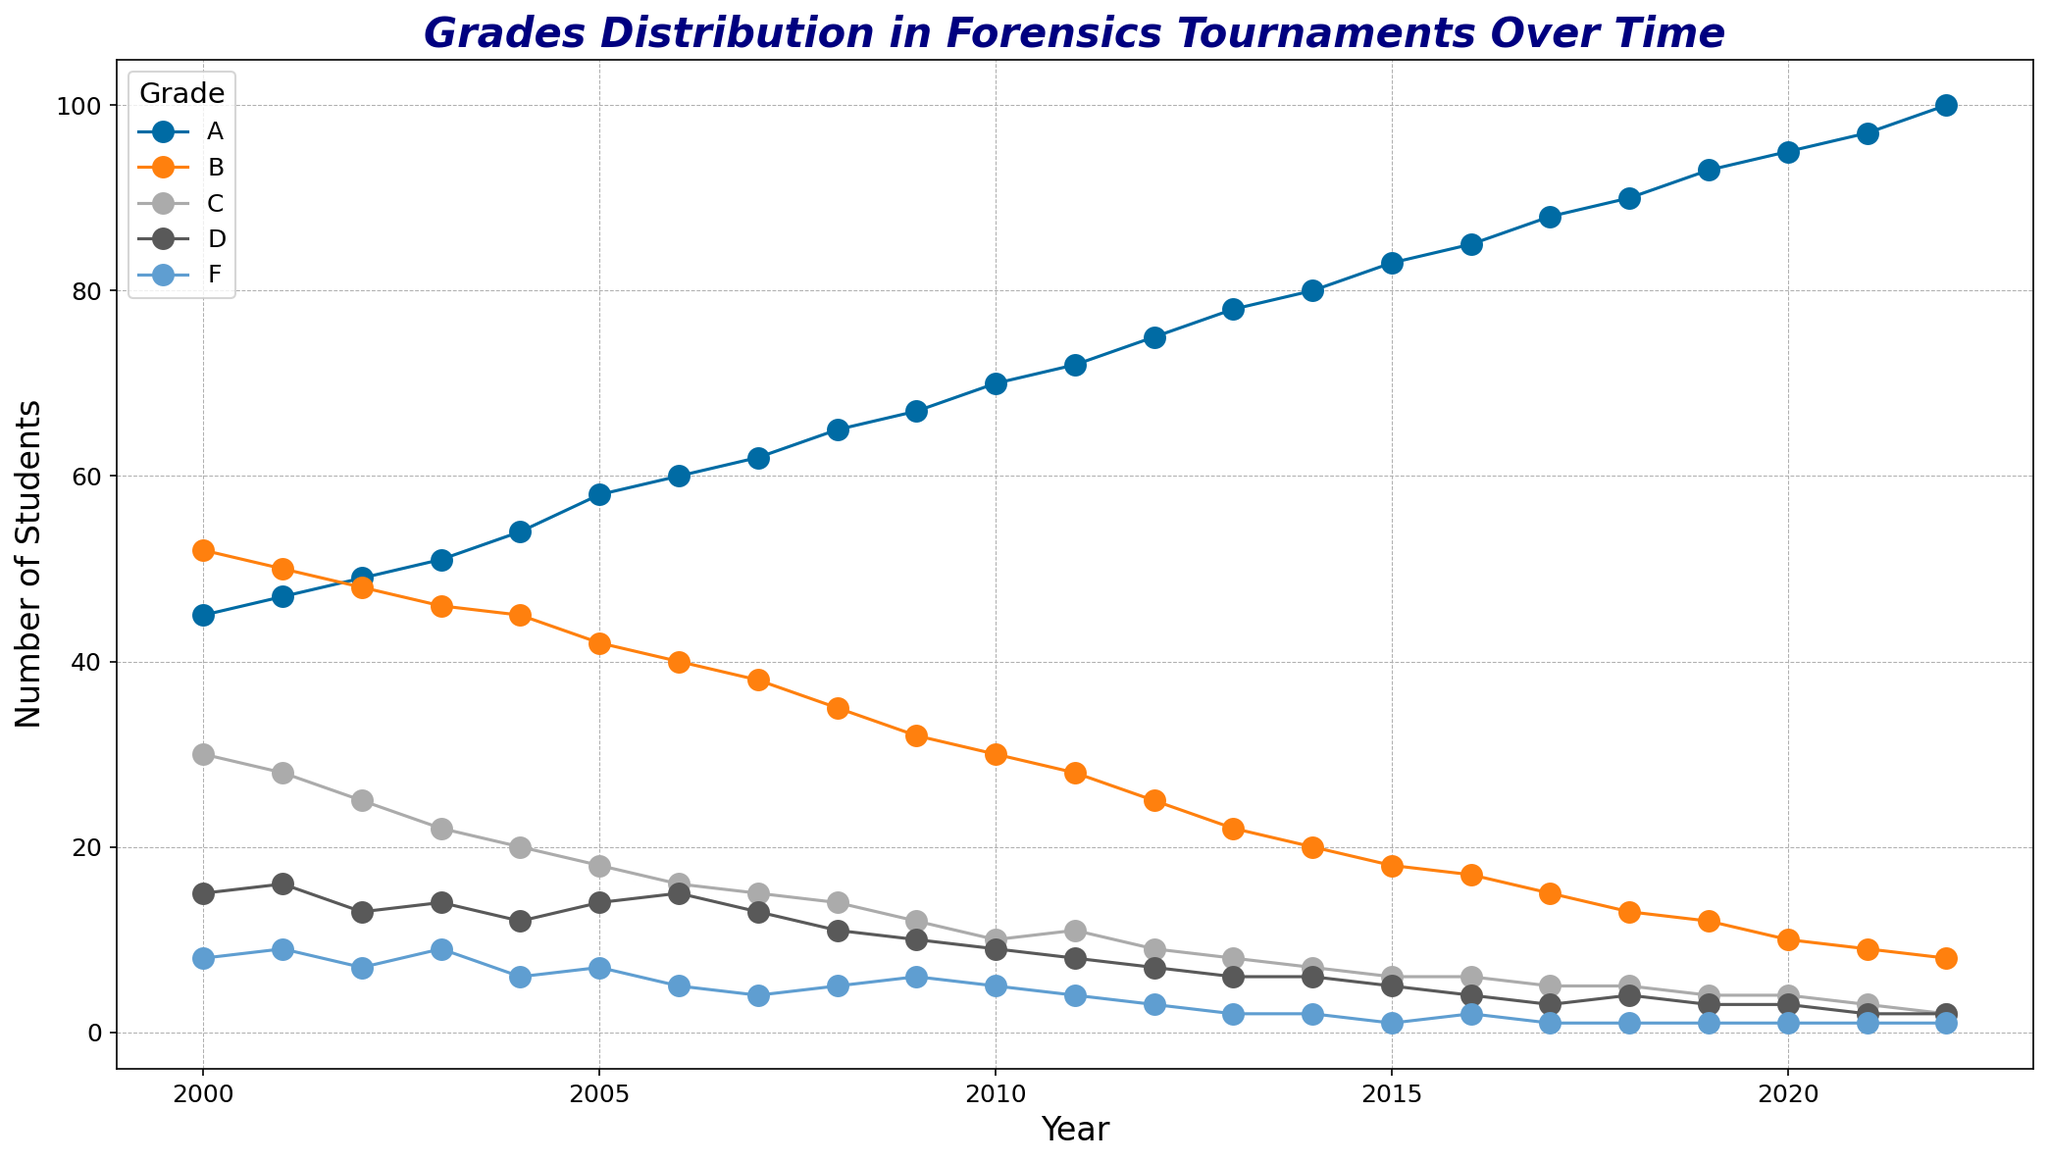Which grade has shown the most students consistently over the years? To determine the grade with the most students consistently, observe the trends for each grade's line over time. The 'A' line is always the highest on the plot.
Answer: 'A' How are the number of students in Grades B and F changing over time? To observe changes over time, look at the slopes of the 'B' and 'F' lines. The 'B' line is decreasing, while the 'F' line remains low with slight fluctuations.
Answer: B is decreasing, F is stable but low What was the total number of students in Grade A and Grade C in the year 2022? Sum the number of students in Grade A and Grade C for 2022. From the figure, Grade A has 100 and Grade C has 2 in 2022. Thus, 100 + 2 = 102.
Answer: 102 Which grade has the steepest positive slope over the years, indicating the most significant increase in the number of students? Look at the trends and steepest slopes for each grade. The 'A' line shows the steepest positive slope, indicating the most significant increase.
Answer: 'A' In which year did Grade B have its highest number of students, and how many were there? Identify the peak of the 'B' line on the plot. The highest number for Grade B appears around the year 2000, with approximately 52 students.
Answer: 2000, 52 Comparing the number of students in Grade D and Grade F in 2015, how many more students were in Grade D than in Grade F? Locate the data points for both grades in 2015 from the plot. Grade D has 5 and Grade F has 1 in 2015. The difference is 5 - 1 = 4.
Answer: 4 What trend can be observed for Grade C over the years? Observe the trajectory of the 'C' line. It shows a general decreasing trend over time, starting from a higher number and declining.
Answer: Decreasing How does the number of students in Grade A in 2010 compare to that in 2000? Find the Grade A values for 2010 and 2000 on the plot. In 2010, it's 70, and in 2000, it's 45. Thus, 70 is greater than 45.
Answer: More in 2010 What is the difference in the number of students in Grade B from 2000 to 2022? Subtract the number of students in Grade B in 2022 from the number in 2000, as observed from the plot. In 2000, it’s 52, and in 2022, it’s 8. So, 52 - 8 = 44.
Answer: 44 